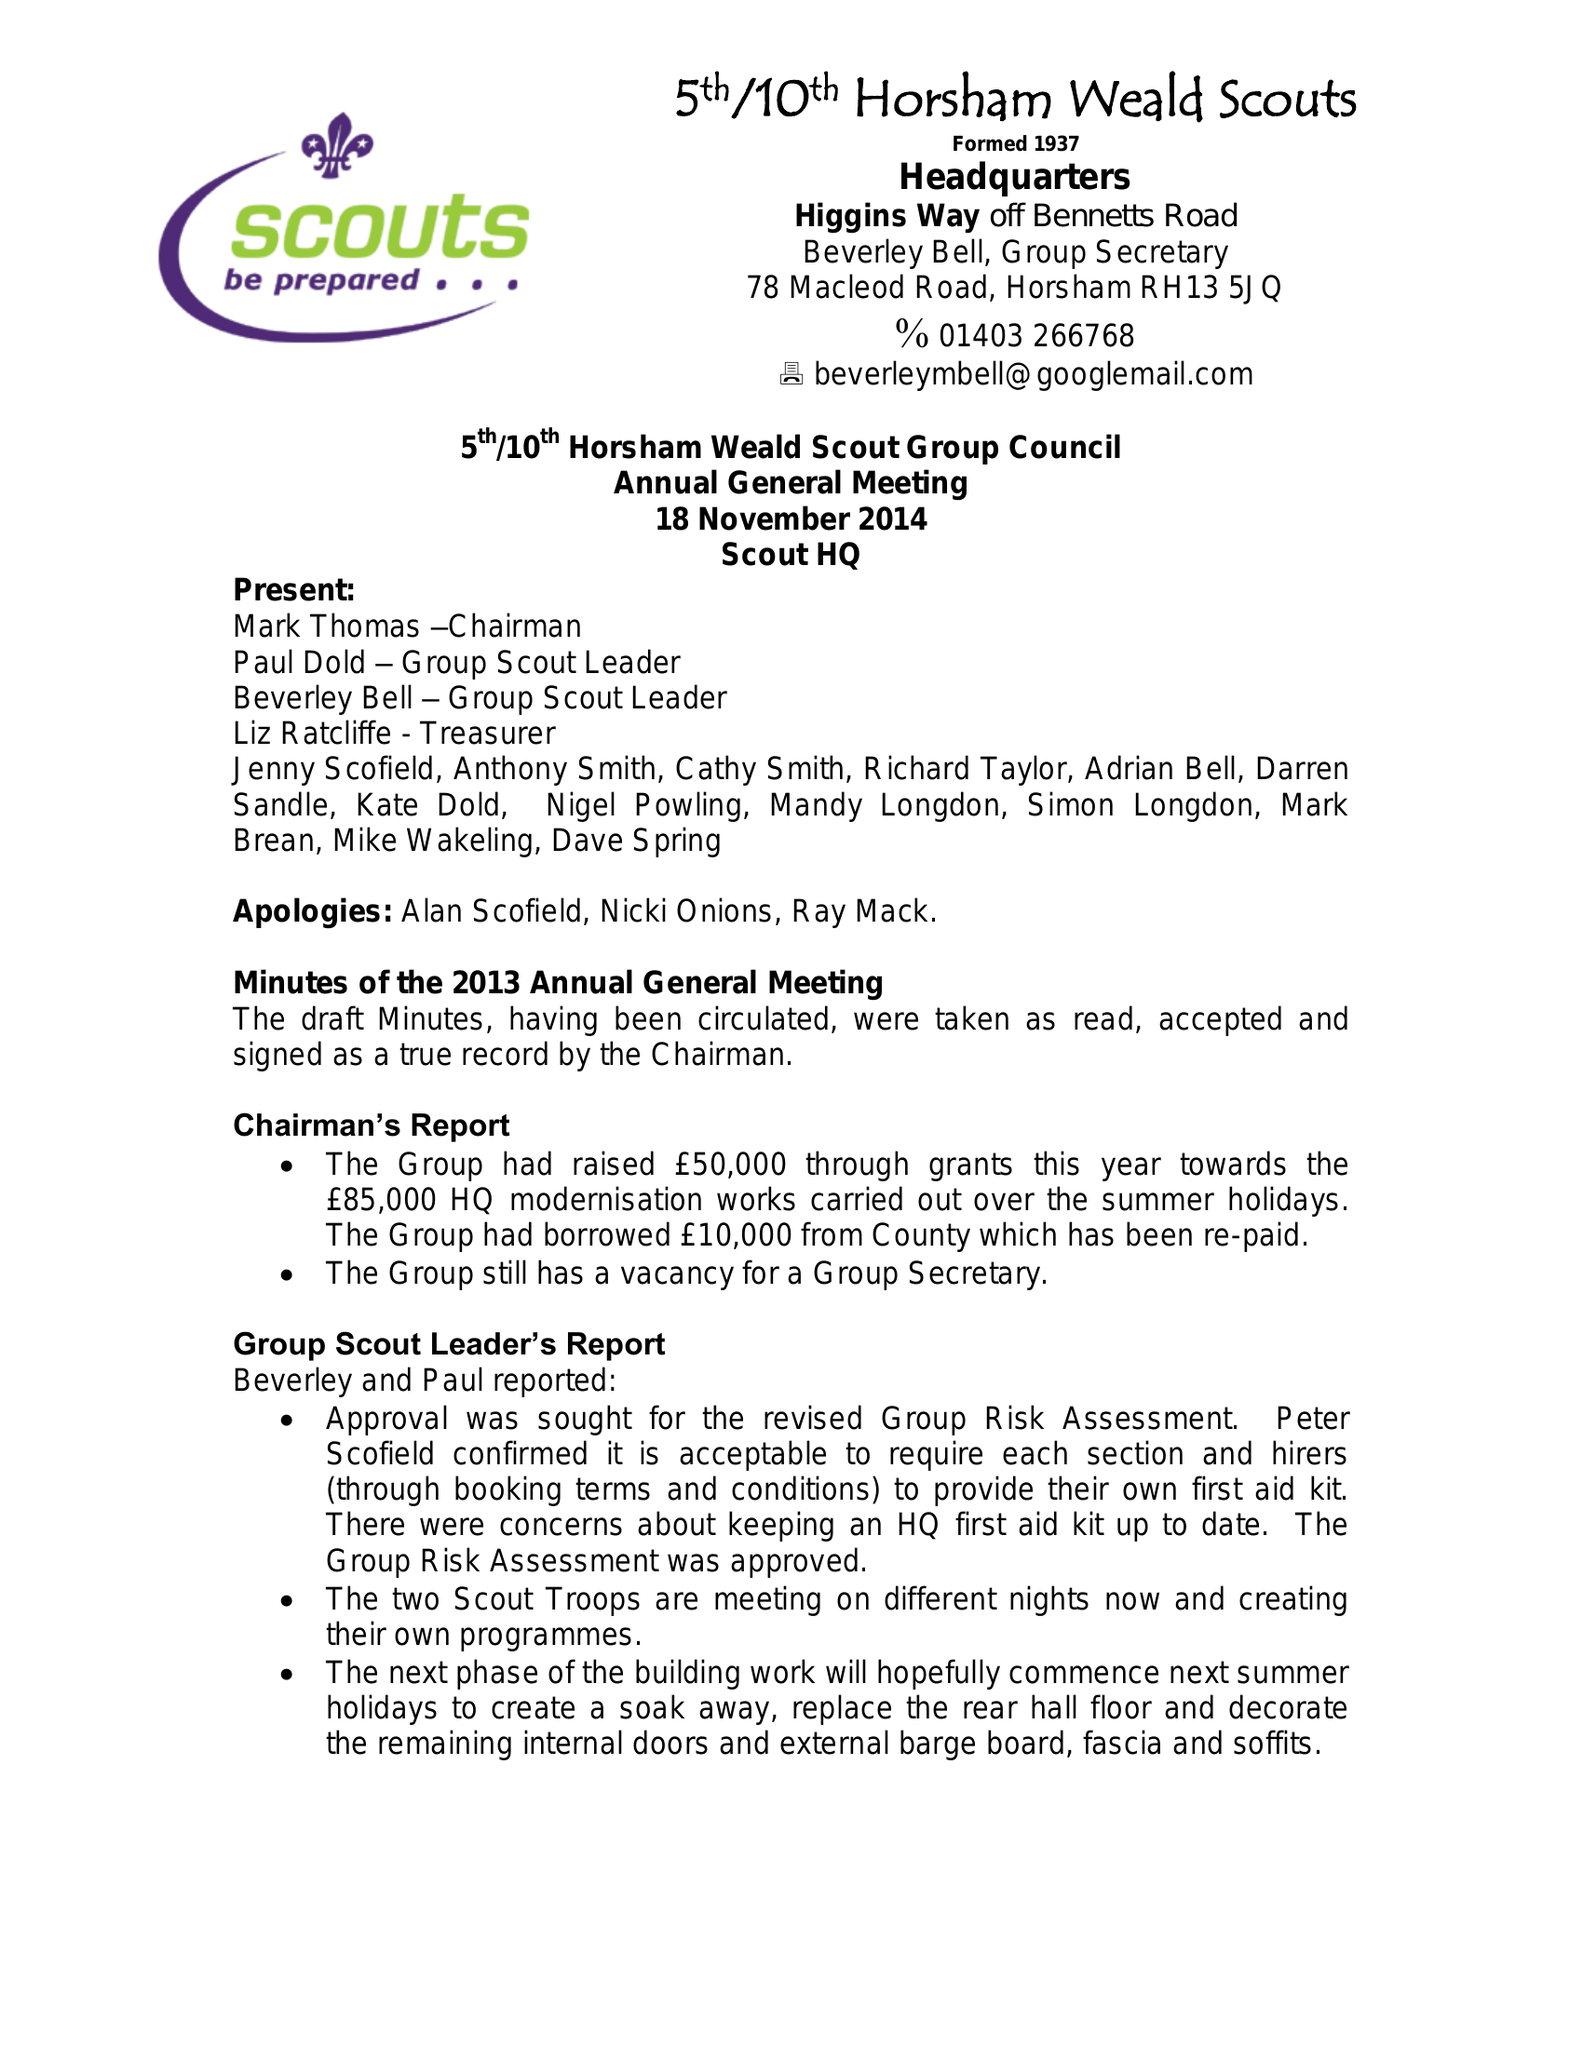What is the value for the spending_annually_in_british_pounds?
Answer the question using a single word or phrase. 41683.00 